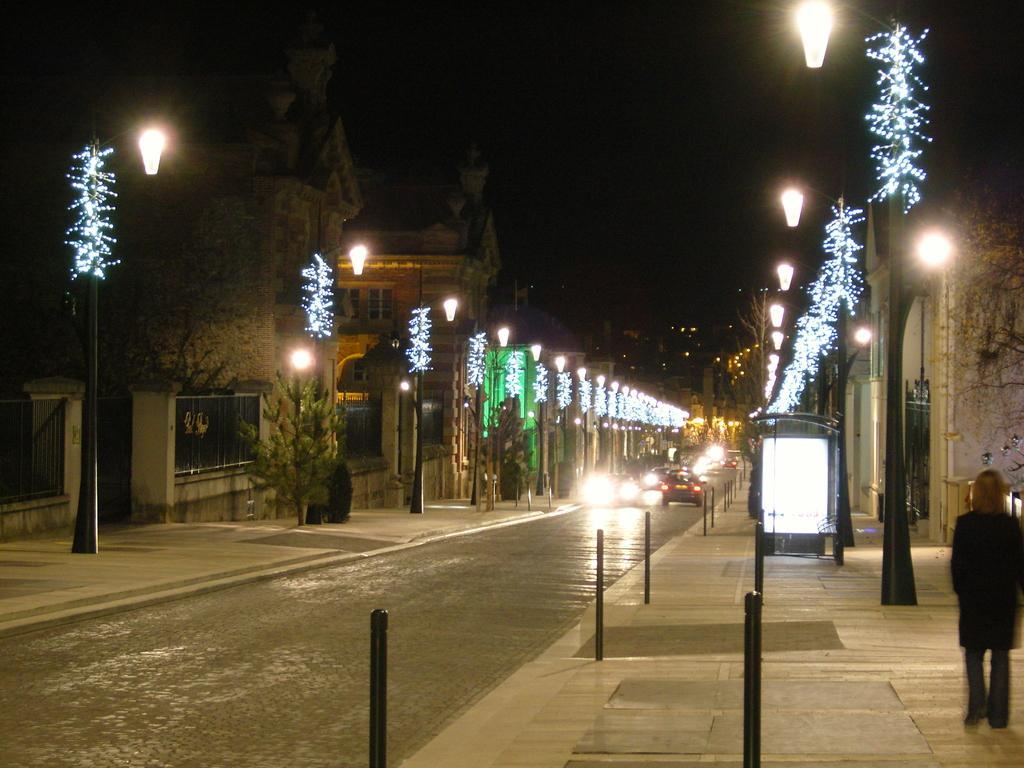Please provide a concise description of this image. In this picture we can see vehicles on the road,here we can see a person on the footpath,lights,trees and in the background we can see it is dark. 